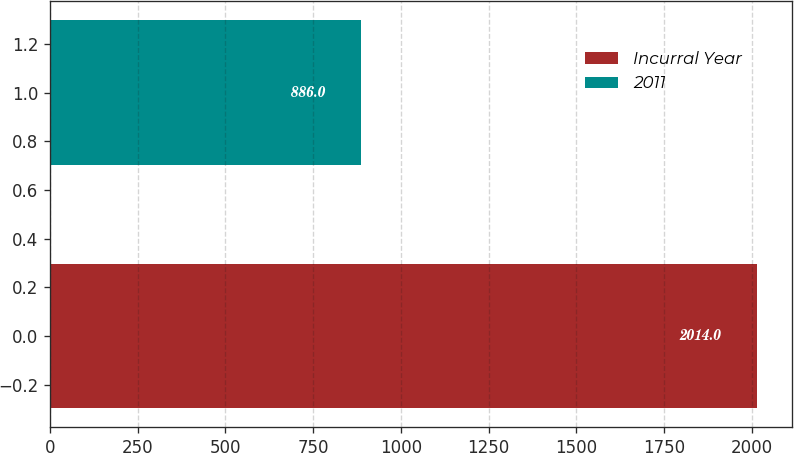<chart> <loc_0><loc_0><loc_500><loc_500><bar_chart><fcel>Incurral Year<fcel>2011<nl><fcel>2014<fcel>886<nl></chart> 